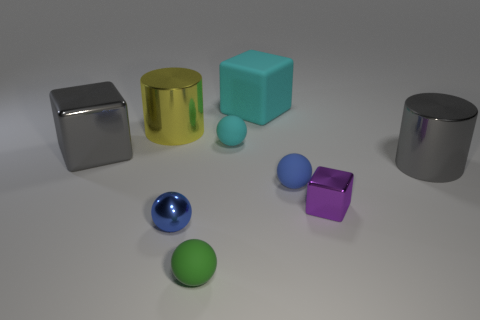Subtract all purple blocks. How many blue balls are left? 2 Subtract all green matte balls. How many balls are left? 3 Subtract all cyan spheres. How many spheres are left? 3 Subtract 2 spheres. How many spheres are left? 2 Subtract all gray spheres. Subtract all purple cubes. How many spheres are left? 4 Subtract all spheres. How many objects are left? 5 Subtract all yellow cylinders. Subtract all tiny blue cylinders. How many objects are left? 8 Add 7 green rubber spheres. How many green rubber spheres are left? 8 Add 5 cyan spheres. How many cyan spheres exist? 6 Subtract 0 green cubes. How many objects are left? 9 